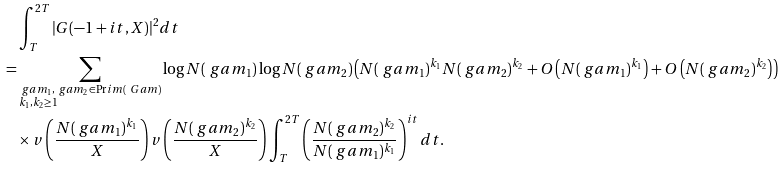<formula> <loc_0><loc_0><loc_500><loc_500>& \int _ { T } ^ { 2 T } | G ( - 1 + i t , X ) | ^ { 2 } d t \\ = & \sum _ { \begin{subarray} { c } \ g a m _ { 1 } , \ g a m _ { 2 } \in \Pr i m ( \ G a m ) \\ k _ { 1 } , k _ { 2 } \geq 1 \end{subarray} } \log { N ( \ g a m _ { 1 } ) } \log { N ( \ g a m _ { 2 } ) } \left ( N ( \ g a m _ { 1 } ) ^ { k _ { 1 } } N ( \ g a m _ { 2 } ) ^ { k _ { 2 } } + O \left ( N ( \ g a m _ { 1 } ) ^ { k _ { 1 } } \right ) + O \left ( N ( \ g a m _ { 2 } ) ^ { k _ { 2 } } \right ) \right ) \\ & \times v \left ( \frac { N ( \ g a m _ { 1 } ) ^ { k _ { 1 } } } { X } \right ) v \left ( \frac { N ( \ g a m _ { 2 } ) ^ { k _ { 2 } } } { X } \right ) \int _ { T } ^ { 2 T } \left ( \frac { N ( \ g a m _ { 2 } ) ^ { k _ { 2 } } } { N ( \ g a m _ { 1 } ) ^ { k _ { 1 } } } \right ) ^ { i t } d t .</formula> 